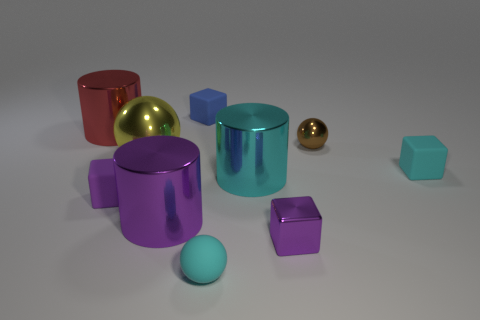The metallic thing that is the same color as the tiny shiny block is what shape?
Provide a short and direct response. Cylinder. What number of matte objects are either big purple spheres or yellow spheres?
Provide a succinct answer. 0. How many objects are big green metal cubes or matte blocks on the right side of the yellow shiny thing?
Provide a succinct answer. 2. Is the size of the matte block that is left of the blue matte cube the same as the large ball?
Offer a very short reply. No. What number of other objects are there of the same shape as the big red object?
Make the answer very short. 2. What number of cyan things are matte blocks or large shiny objects?
Your answer should be very brief. 2. Is the color of the matte block right of the tiny blue rubber block the same as the tiny matte sphere?
Provide a succinct answer. Yes. What is the shape of the big purple thing that is the same material as the red cylinder?
Give a very brief answer. Cylinder. The metallic thing that is behind the big yellow thing and to the left of the purple metallic cylinder is what color?
Your response must be concise. Red. What is the size of the metallic cylinder left of the ball on the left side of the matte sphere?
Your response must be concise. Large. 